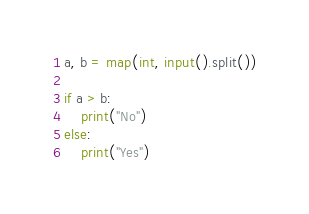<code> <loc_0><loc_0><loc_500><loc_500><_Python_>
a, b = map(int, input().split())

if a > b:
    print("No")
else:
    print("Yes")</code> 